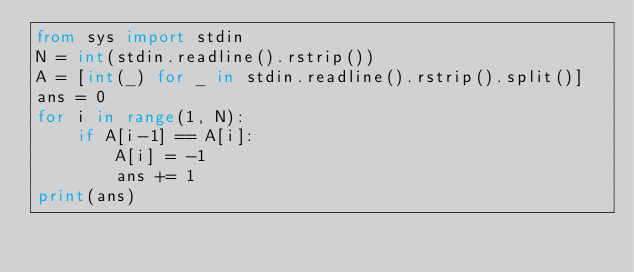Convert code to text. <code><loc_0><loc_0><loc_500><loc_500><_Python_>from sys import stdin
N = int(stdin.readline().rstrip())
A = [int(_) for _ in stdin.readline().rstrip().split()]
ans = 0
for i in range(1, N):
    if A[i-1] == A[i]:
        A[i] = -1
        ans += 1
print(ans)</code> 